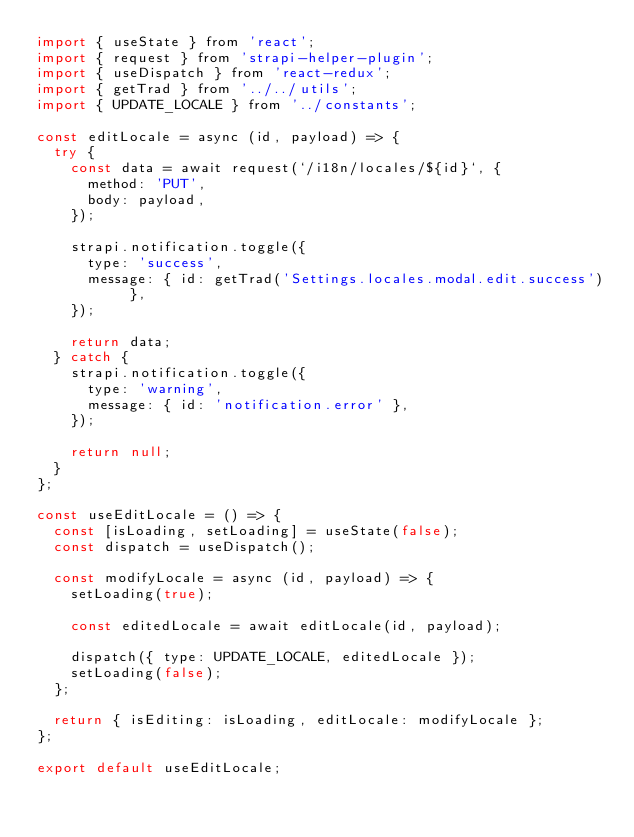<code> <loc_0><loc_0><loc_500><loc_500><_JavaScript_>import { useState } from 'react';
import { request } from 'strapi-helper-plugin';
import { useDispatch } from 'react-redux';
import { getTrad } from '../../utils';
import { UPDATE_LOCALE } from '../constants';

const editLocale = async (id, payload) => {
  try {
    const data = await request(`/i18n/locales/${id}`, {
      method: 'PUT',
      body: payload,
    });

    strapi.notification.toggle({
      type: 'success',
      message: { id: getTrad('Settings.locales.modal.edit.success') },
    });

    return data;
  } catch {
    strapi.notification.toggle({
      type: 'warning',
      message: { id: 'notification.error' },
    });

    return null;
  }
};

const useEditLocale = () => {
  const [isLoading, setLoading] = useState(false);
  const dispatch = useDispatch();

  const modifyLocale = async (id, payload) => {
    setLoading(true);

    const editedLocale = await editLocale(id, payload);

    dispatch({ type: UPDATE_LOCALE, editedLocale });
    setLoading(false);
  };

  return { isEditing: isLoading, editLocale: modifyLocale };
};

export default useEditLocale;
</code> 